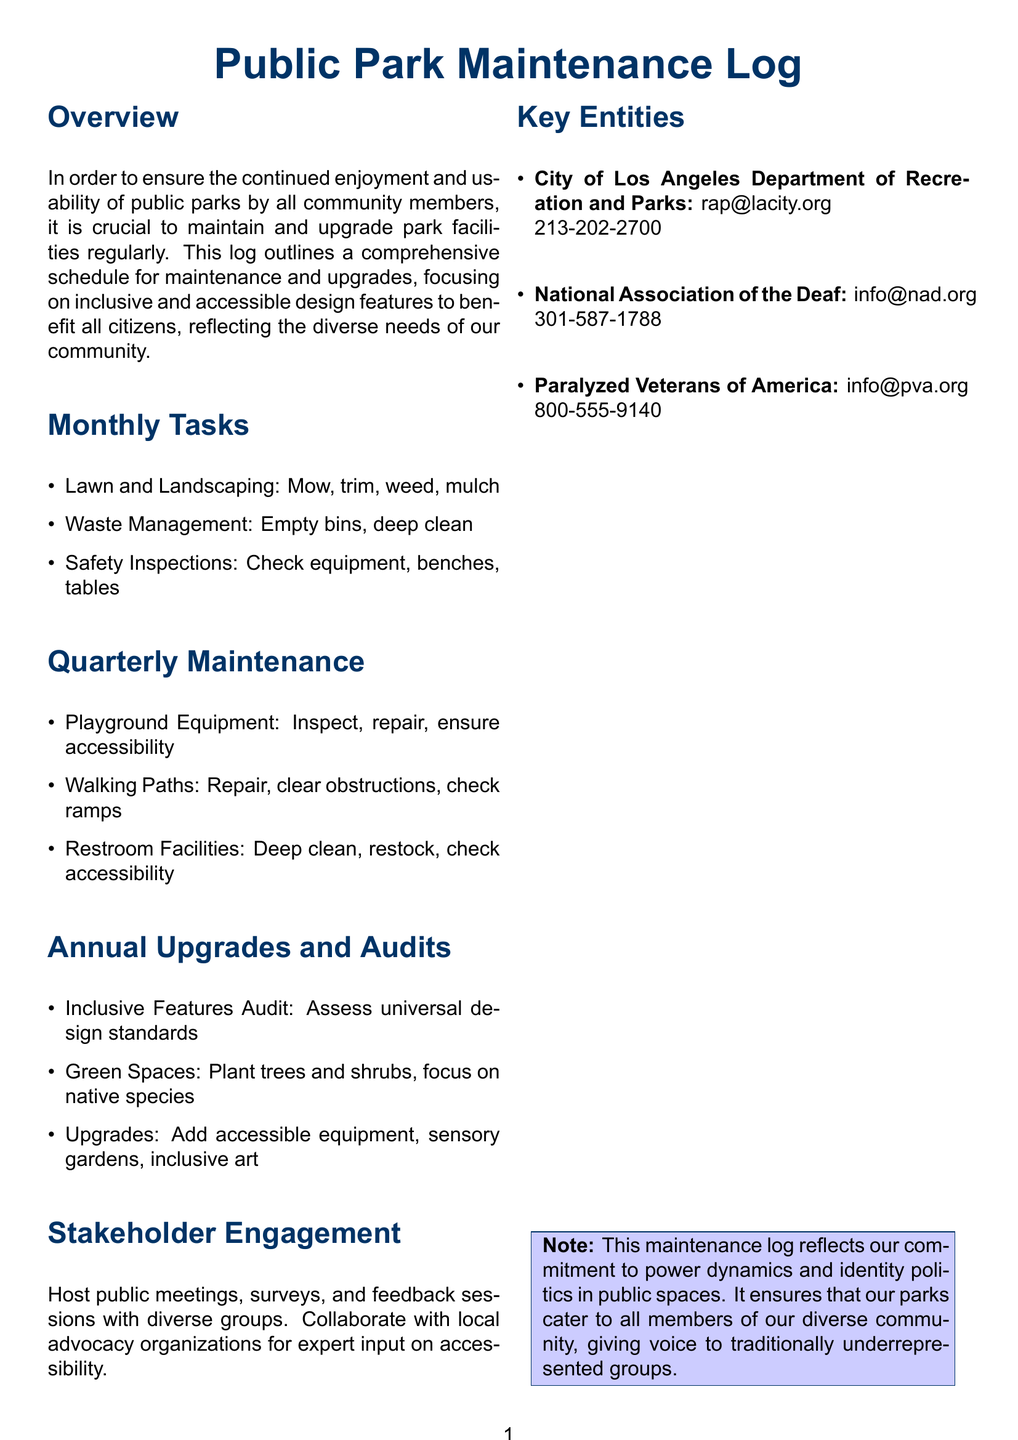What are the monthly tasks for park maintenance? The monthly tasks include lawn and landscaping, waste management, and safety inspections as detailed in the document.
Answer: Lawn and Landscaping, Waste Management, Safety Inspections How often are playground equipment inspections scheduled? The document specifies that playground equipment inspections are part of the quarterly maintenance tasks.
Answer: Quarterly What is one of the goals of the annual upgrades? The document highlights that one of the goals is to assess universal design standards for inclusive features.
Answer: Assess universal design standards Which department manages the public parks in Los Angeles? The document lists the City of Los Angeles Department of Recreation and Parks as the managing entity.
Answer: City of Los Angeles Department of Recreation and Parks What type of engagement is encouraged for community input? The document mentions hosting public meetings, surveys, and feedback sessions.
Answer: Public meetings, surveys, and feedback sessions What is the focus of the "Green Spaces" task in annual upgrades? The document states that the focus is on planting trees and shrubs, particularly native species.
Answer: Native species 